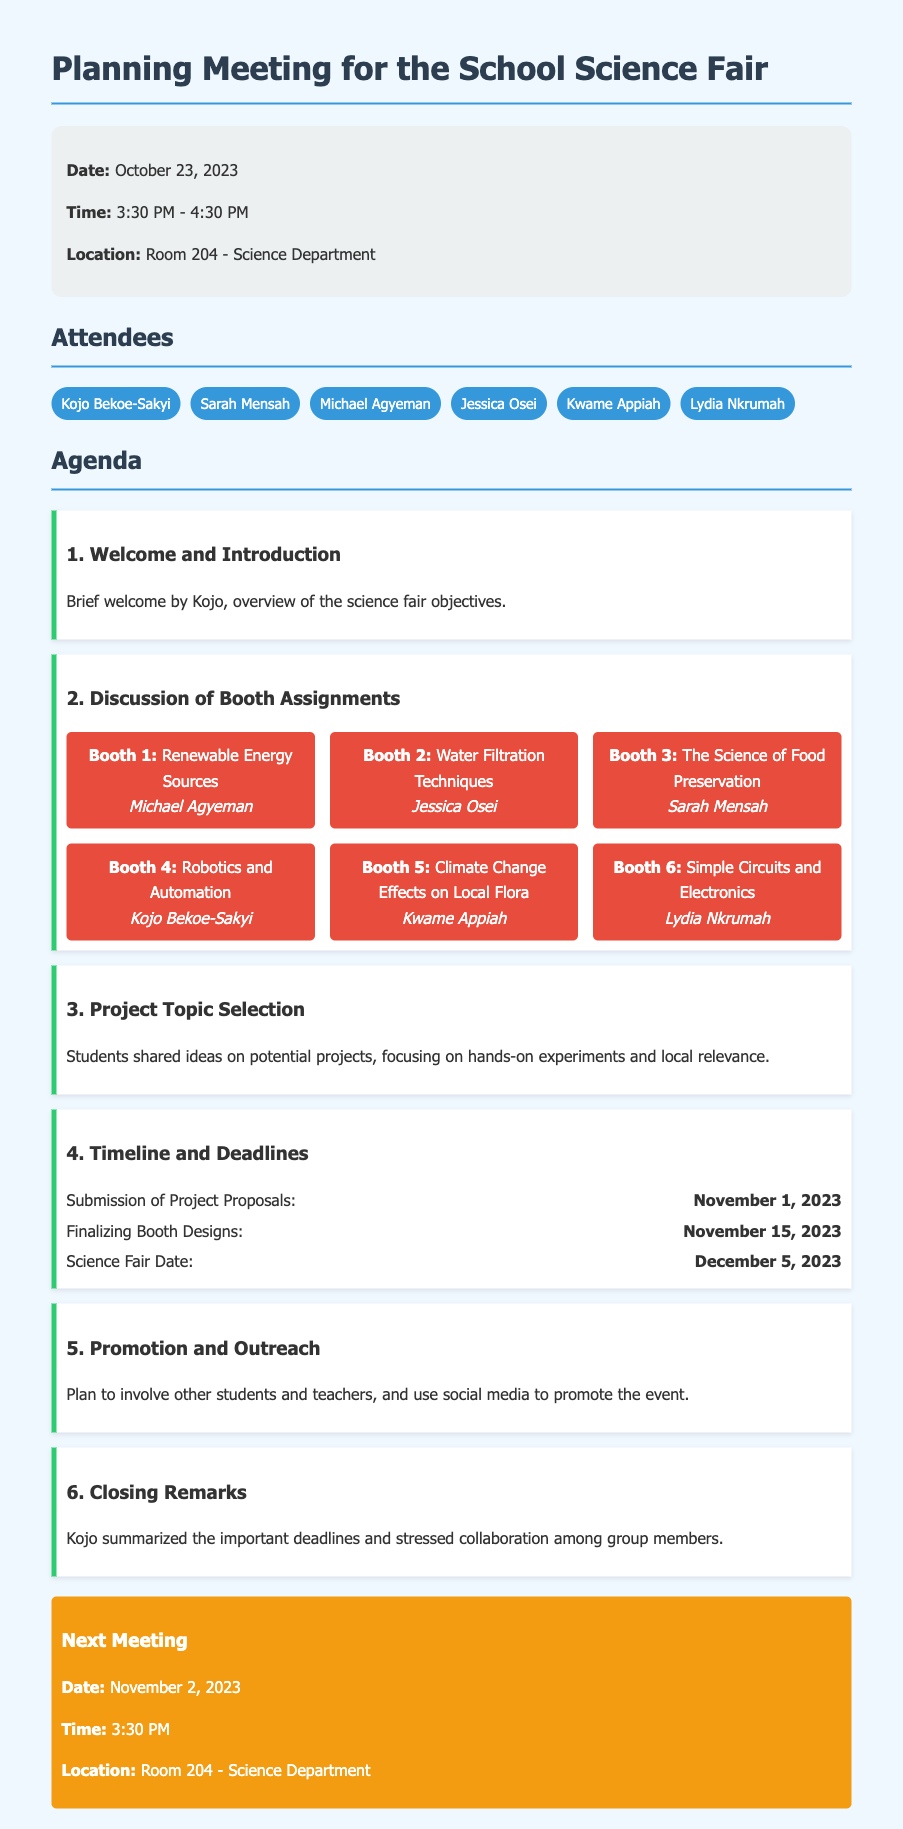What is the date of the science fair? The science fair is scheduled for December 5, 2023, as mentioned in the timeline section.
Answer: December 5, 2023 Who is assigned to Booth 4? In the booth assignments, Booth 4 is designated for Kojo Bekoe-Sakyi to work on Robotics and Automation.
Answer: Kojo Bekoe-Sakyi What time did the meeting start? The meeting was held from 3:30 PM to 4:30 PM, so it started at 3:30 PM.
Answer: 3:30 PM What is the final deadline for project proposal submissions? According to the timeline, project proposals must be submitted by November 1, 2023.
Answer: November 1, 2023 How many attendees were present at the meeting? There were six attendees listed in the document, as shown in the attendees section.
Answer: Six What is the purpose of the meeting? The meeting aimed to plan for the school science fair, including booth assignments and project topics.
Answer: Planning for the school science fair What is discussed in the 'Promotion and Outreach' agenda item? The document mentions involving other students and teachers and using social media for event promotion.
Answer: Involve other students and teachers, use social media What is the location of the next meeting? The next meeting is scheduled to take place in Room 204 of the Science Department, as specified in the meeting details.
Answer: Room 204 - Science Department 